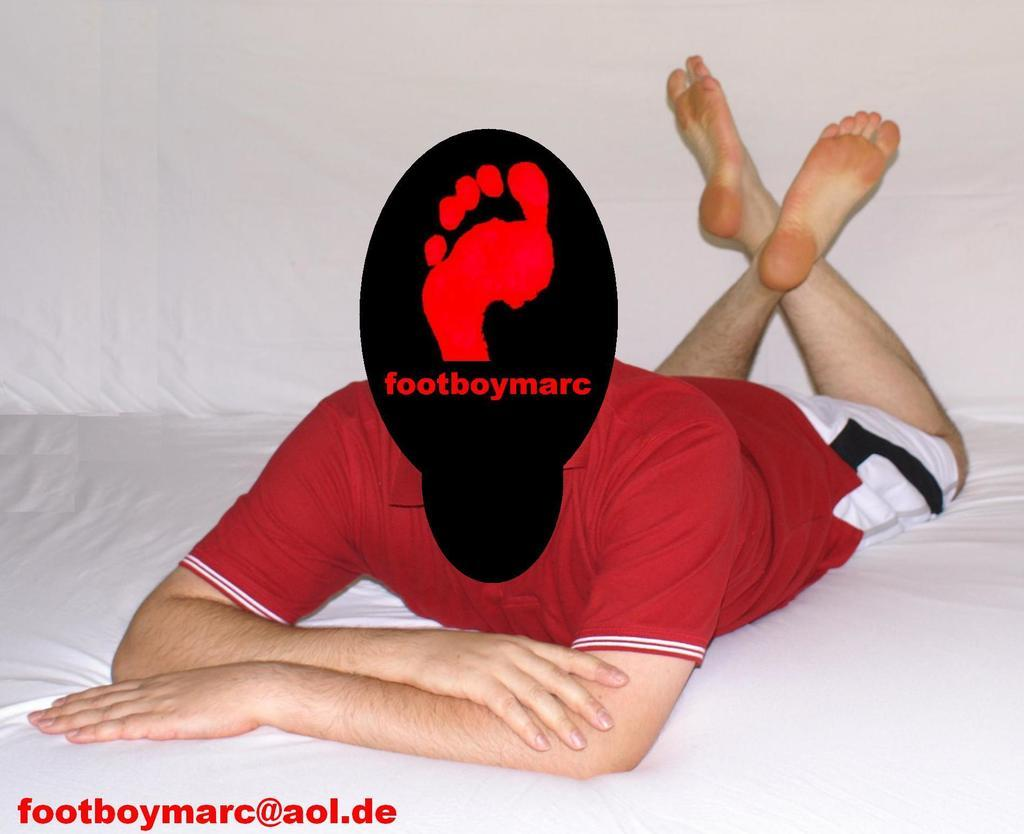<image>
Share a concise interpretation of the image provided. A picture with a male sitting on a bed with their face blacked out and the sign footboymarc. 